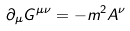Convert formula to latex. <formula><loc_0><loc_0><loc_500><loc_500>\partial _ { \mu } G ^ { \mu \nu } = - m ^ { 2 } A ^ { \nu }</formula> 